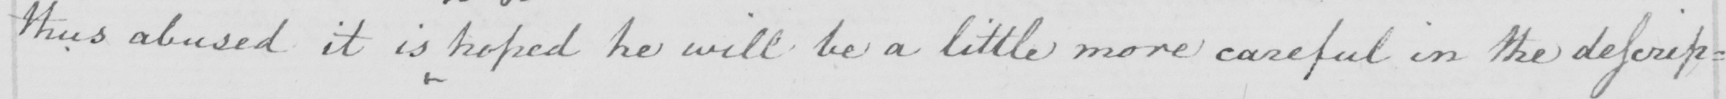Transcribe the text shown in this historical manuscript line. thus abused it is hoped he will be a little more careful in the descrip= 